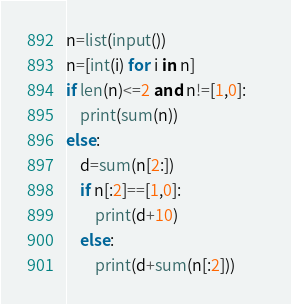<code> <loc_0><loc_0><loc_500><loc_500><_Python_>n=list(input())
n=[int(i) for i in n]
if len(n)<=2 and n!=[1,0]:
    print(sum(n))
else:
    d=sum(n[2:])
    if n[:2]==[1,0]:
        print(d+10)
    else:
        print(d+sum(n[:2]))        </code> 